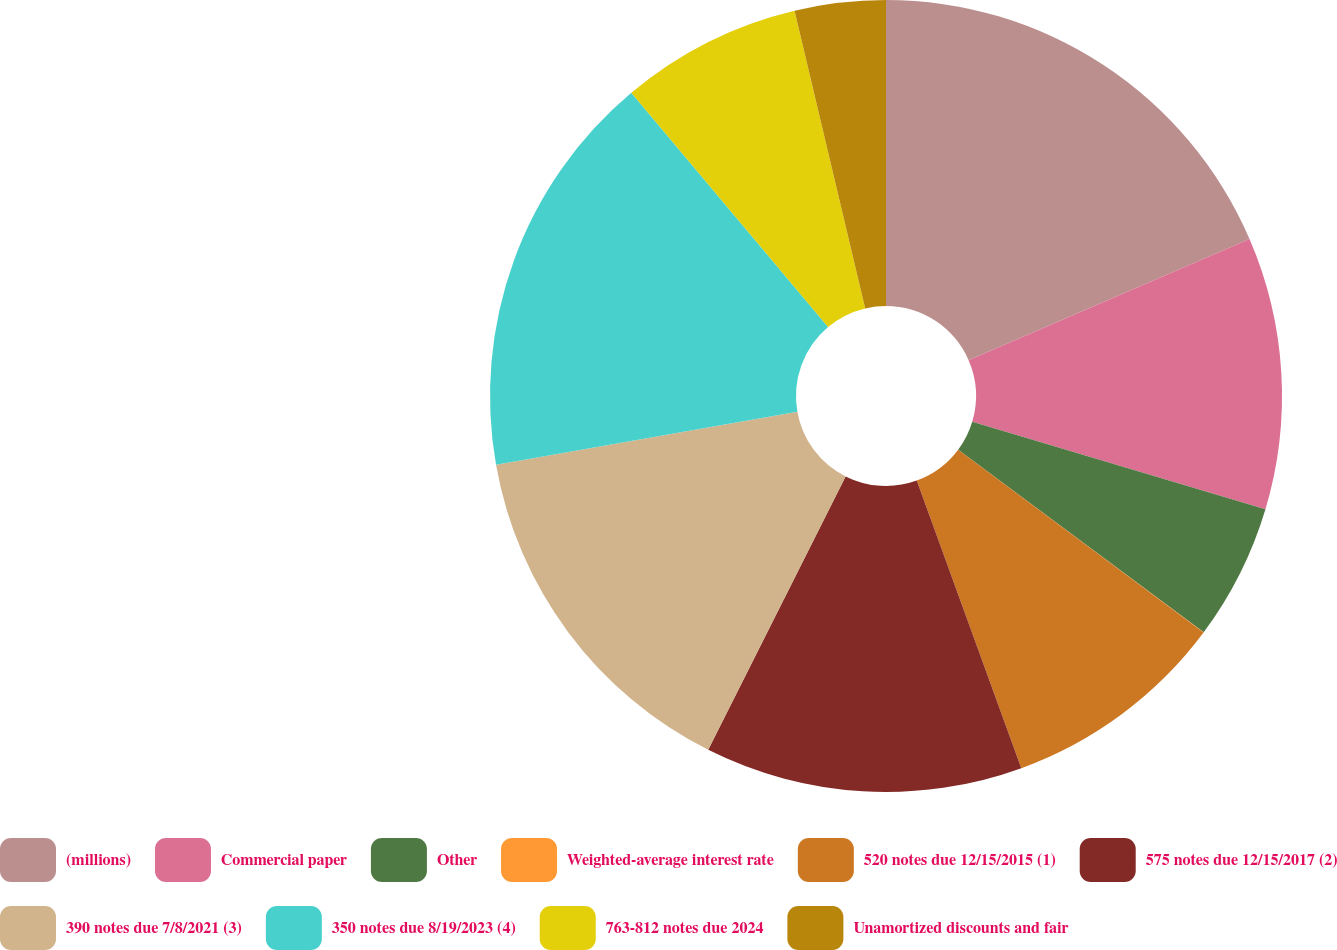Convert chart to OTSL. <chart><loc_0><loc_0><loc_500><loc_500><pie_chart><fcel>(millions)<fcel>Commercial paper<fcel>Other<fcel>Weighted-average interest rate<fcel>520 notes due 12/15/2015 (1)<fcel>575 notes due 12/15/2017 (2)<fcel>390 notes due 7/8/2021 (3)<fcel>350 notes due 8/19/2023 (4)<fcel>763-812 notes due 2024<fcel>Unamortized discounts and fair<nl><fcel>18.51%<fcel>11.11%<fcel>5.56%<fcel>0.01%<fcel>9.26%<fcel>12.96%<fcel>14.81%<fcel>16.66%<fcel>7.41%<fcel>3.71%<nl></chart> 